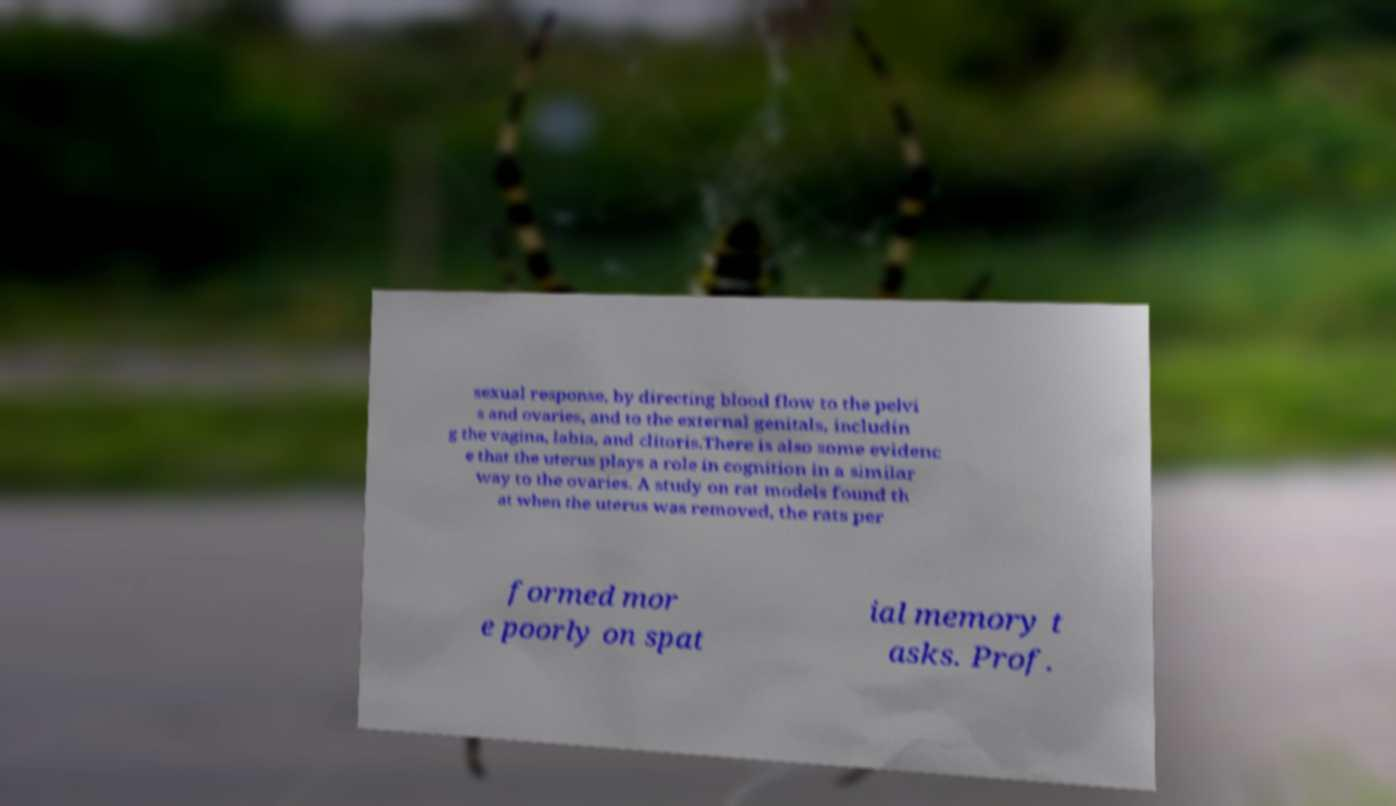Could you extract and type out the text from this image? sexual response, by directing blood flow to the pelvi s and ovaries, and to the external genitals, includin g the vagina, labia, and clitoris.There is also some evidenc e that the uterus plays a role in cognition in a similar way to the ovaries. A study on rat models found th at when the uterus was removed, the rats per formed mor e poorly on spat ial memory t asks. Prof. 